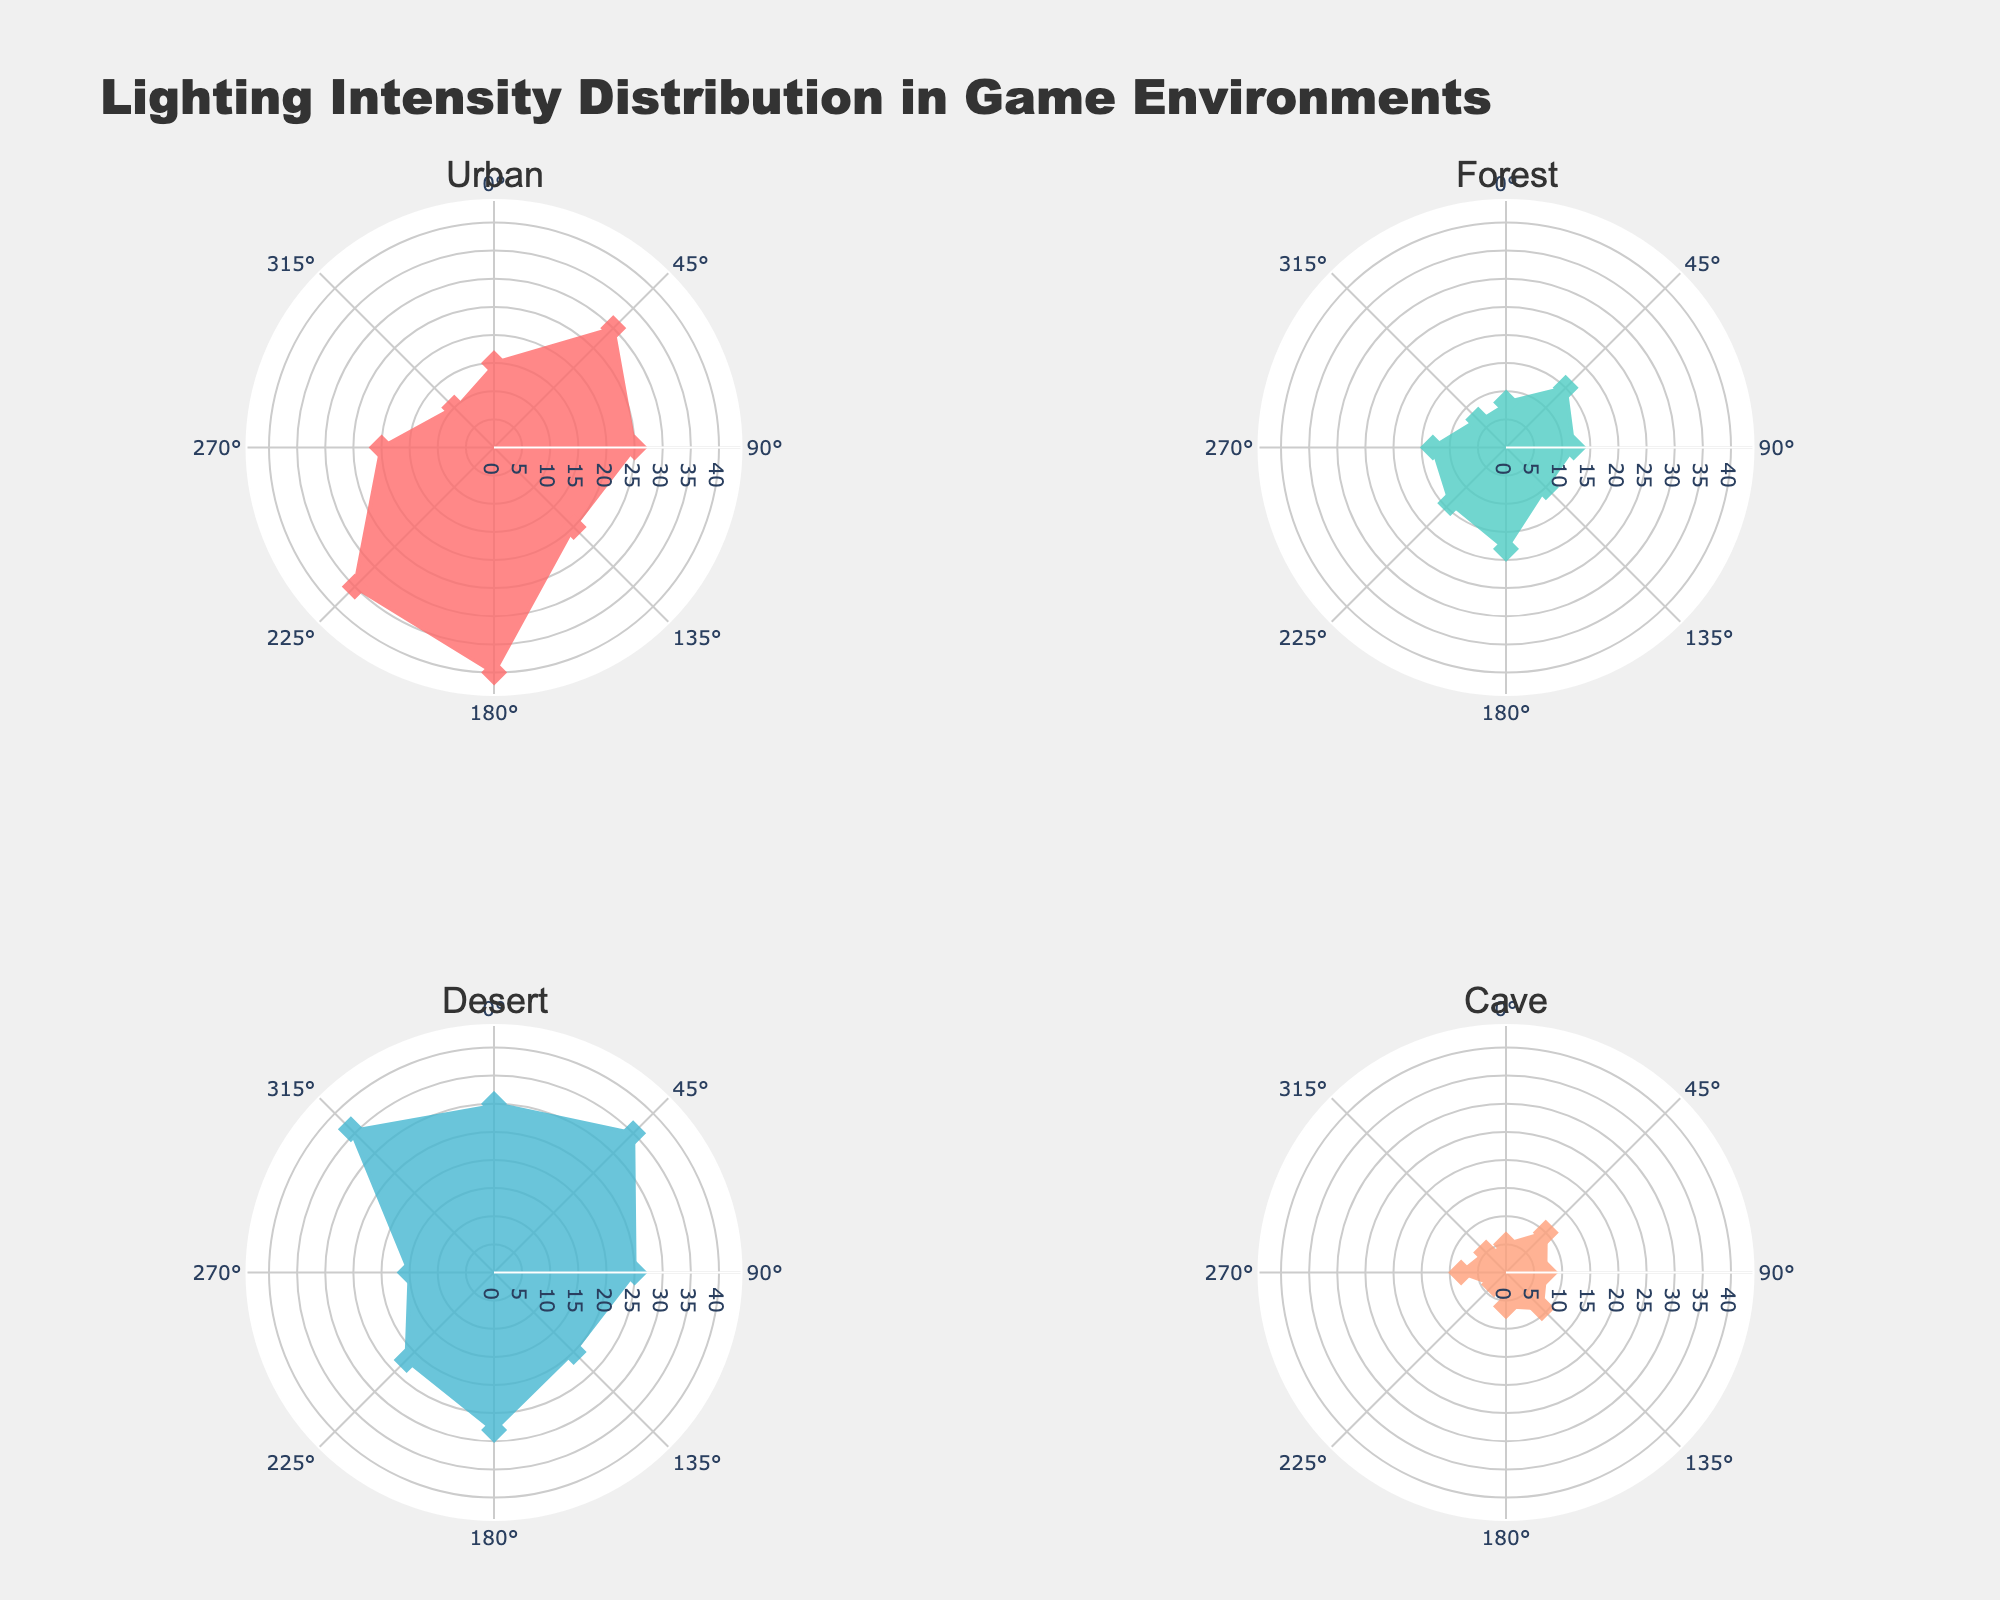What is the title of the figure? The title is located at the top of the figure, in a larger and bold font compared to other text elements.
Answer: Lighting Intensity Distribution in Game Environments How many subplots are presented in the figure? There are individual sections within the figure, each with its own polar coordinates and title. By counting these sections, we can determine the number of subplots.
Answer: 4 Which environment shows the highest lighting intensity? By looking at the subplot for each environment and identifying the longest radius (distance from the center to the edge) in the rose chart, we can determine which environment has the highest peak. The Desert environment has the highest peak at 36.
Answer: Desert In the Cave environment, what is the lighting intensity at 225 degrees? Locate the Cave environment subplot and find the value at the angle 225 degrees, which is where the intensity data point is plotted. The value is 3.
Answer: 3 Compare the lighting intensity of the North regions across all environments. Which one has the least intensity? Go through each environment's subplot and identify the lighting intensity value at the 0-degree mark (North). Compare these values to determine which one is the smallest. The Cave environment has the smallest intensity at 5.
Answer: Cave On average, which environment has the highest lighting intensity? Calculate the average intensity for each environment by summing the values and dividing by the number of data points, then compare those averages. The Desert environment has the highest average intensity.
Answer: Desert Which direction has the highest lighting intensity in the Urban environment? Look at the Urban environment subplot and find the direction with the largest radius from the center to the edge; this indicates the highest intensity. The North-East direction has the highest intensity at 40.
Answer: North-East Is the lighting intensity more uniformly distributed in the Forest environment compared to the Urban environment? Assess the variation in radius lengths for both the Forest and Urban subplots. The Forest environment has a more uniform distribution because its radii are closer in length.
Answer: Yes 